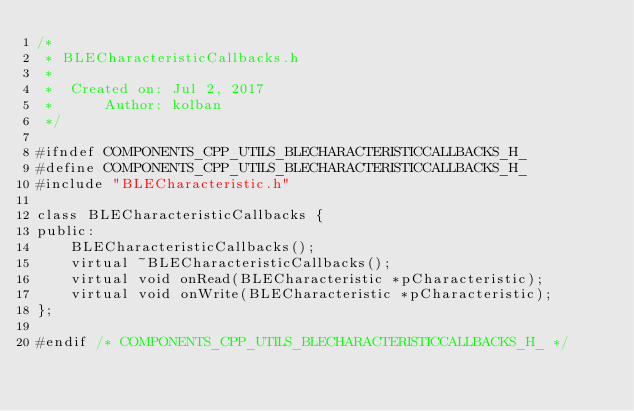Convert code to text. <code><loc_0><loc_0><loc_500><loc_500><_C_>/*
 * BLECharacteristicCallbacks.h
 *
 *  Created on: Jul 2, 2017
 *      Author: kolban
 */

#ifndef COMPONENTS_CPP_UTILS_BLECHARACTERISTICCALLBACKS_H_
#define COMPONENTS_CPP_UTILS_BLECHARACTERISTICCALLBACKS_H_
#include "BLECharacteristic.h"

class BLECharacteristicCallbacks {
public:
	BLECharacteristicCallbacks();
	virtual ~BLECharacteristicCallbacks();
	virtual void onRead(BLECharacteristic *pCharacteristic);
	virtual void onWrite(BLECharacteristic *pCharacteristic);
};

#endif /* COMPONENTS_CPP_UTILS_BLECHARACTERISTICCALLBACKS_H_ */
</code> 